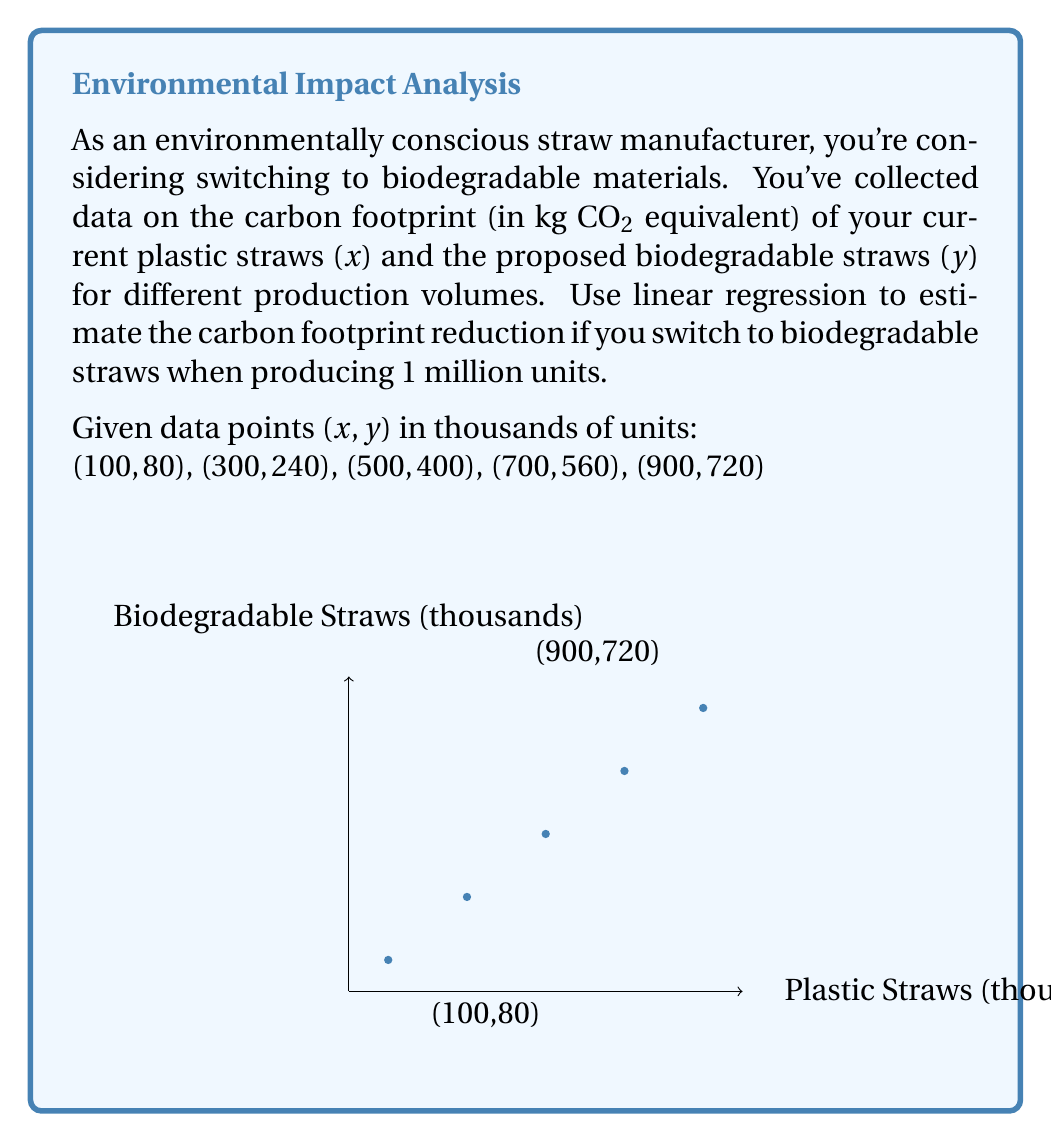Solve this math problem. Let's approach this step-by-step:

1) First, we need to find the linear regression equation. The form is $y = mx + b$, where $m$ is the slope and $b$ is the y-intercept.

2) To calculate the slope $m$:
   $m = \frac{n\sum xy - \sum x \sum y}{n\sum x^2 - (\sum x)^2}$
   
   $\sum x = 2500$, $\sum y = 2000$, $\sum xy = 2,000,000$, $\sum x^2 = 1,950,000$, $n = 5$
   
   $m = \frac{5(2,000,000) - 2500(2000)}{5(1,950,000) - 2500^2} = \frac{10,000,000 - 5,000,000}{9,750,000 - 6,250,000} = \frac{5,000,000}{3,500,000} = 0.8$

3) To find $b$, use the point-slope form with the mean of x and y:
   $\bar{x} = 500$, $\bar{y} = 400$
   $400 = 0.8(500) + b$
   $b = 400 - 400 = 0$

4) The regression equation is $y = 0.8x$

5) For 1 million plastic straws (x = 1000):
   Plastic footprint: $1000 * 1 = 1000$ kg CO2
   Biodegradable footprint: $y = 0.8 * 1000 = 800$ kg CO2

6) Carbon footprint reduction:
   $1000 - 800 = 200$ kg CO2
Answer: 200 kg CO2 